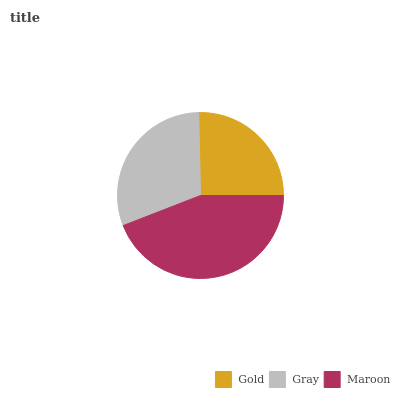Is Gold the minimum?
Answer yes or no. Yes. Is Maroon the maximum?
Answer yes or no. Yes. Is Gray the minimum?
Answer yes or no. No. Is Gray the maximum?
Answer yes or no. No. Is Gray greater than Gold?
Answer yes or no. Yes. Is Gold less than Gray?
Answer yes or no. Yes. Is Gold greater than Gray?
Answer yes or no. No. Is Gray less than Gold?
Answer yes or no. No. Is Gray the high median?
Answer yes or no. Yes. Is Gray the low median?
Answer yes or no. Yes. Is Gold the high median?
Answer yes or no. No. Is Maroon the low median?
Answer yes or no. No. 